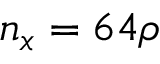<formula> <loc_0><loc_0><loc_500><loc_500>n _ { x } = 6 4 \rho</formula> 